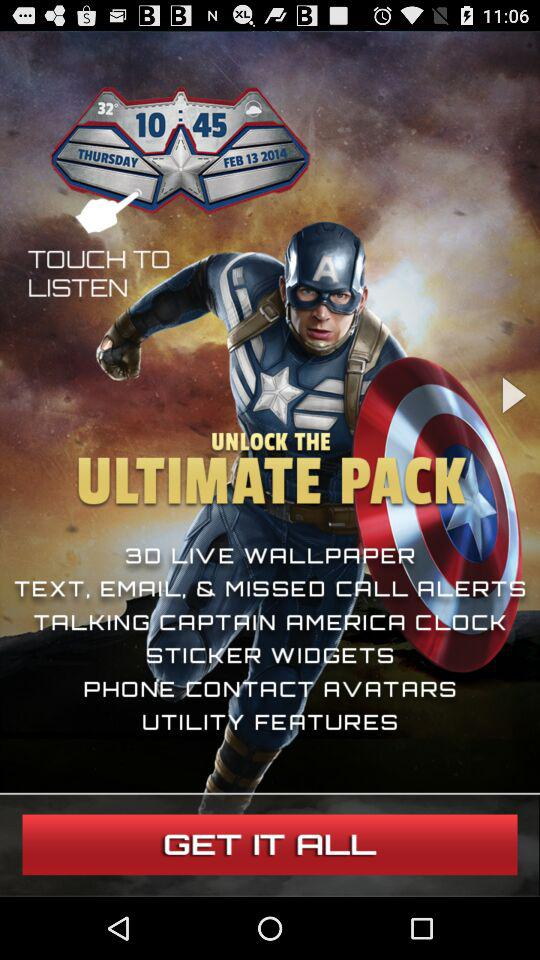Which day was February 13, 2014? The day was Thursday. 